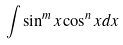Convert formula to latex. <formula><loc_0><loc_0><loc_500><loc_500>\int \sin ^ { m } x \cos ^ { n } x d x</formula> 